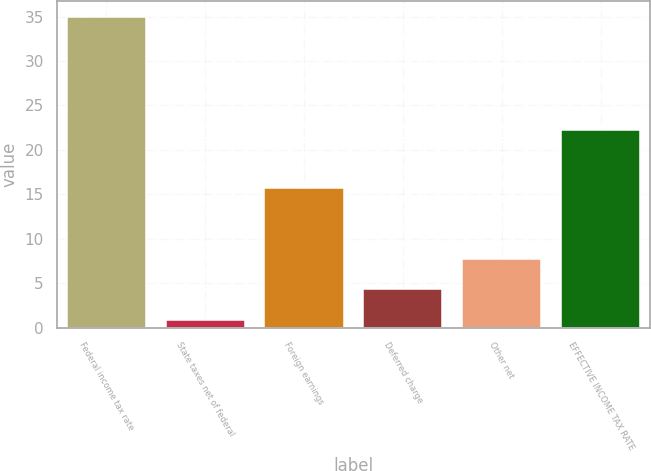<chart> <loc_0><loc_0><loc_500><loc_500><bar_chart><fcel>Federal income tax rate<fcel>State taxes net of federal<fcel>Foreign earnings<fcel>Deferred charge<fcel>Other net<fcel>EFFECTIVE INCOME TAX RATE<nl><fcel>35<fcel>0.9<fcel>15.7<fcel>4.31<fcel>7.72<fcel>22.2<nl></chart> 